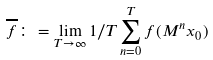<formula> <loc_0><loc_0><loc_500><loc_500>\overline { f } \colon = \lim _ { T \to \infty } 1 / T \sum _ { n = 0 } ^ { T } f ( M ^ { n } x _ { 0 } )</formula> 